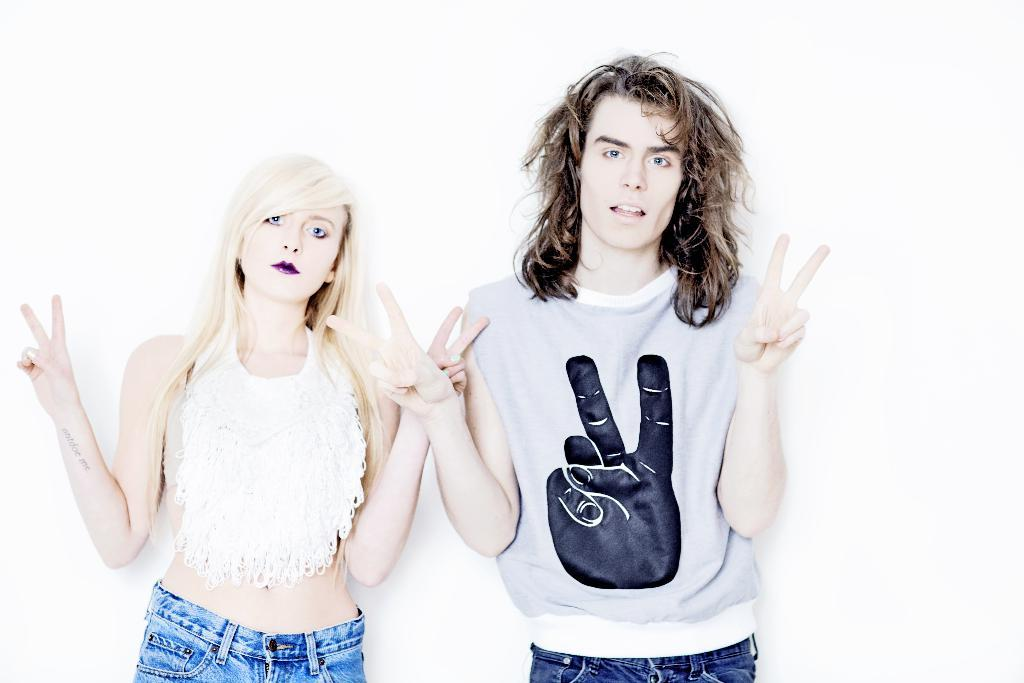How many people are in the image? There are two people in the image, a man and a woman. What are the positions of the man and the woman in the image? Both the man and the woman are standing in the image. What type of pencil is the man holding in the image? There is no pencil present in the image; the man is not holding any object. 